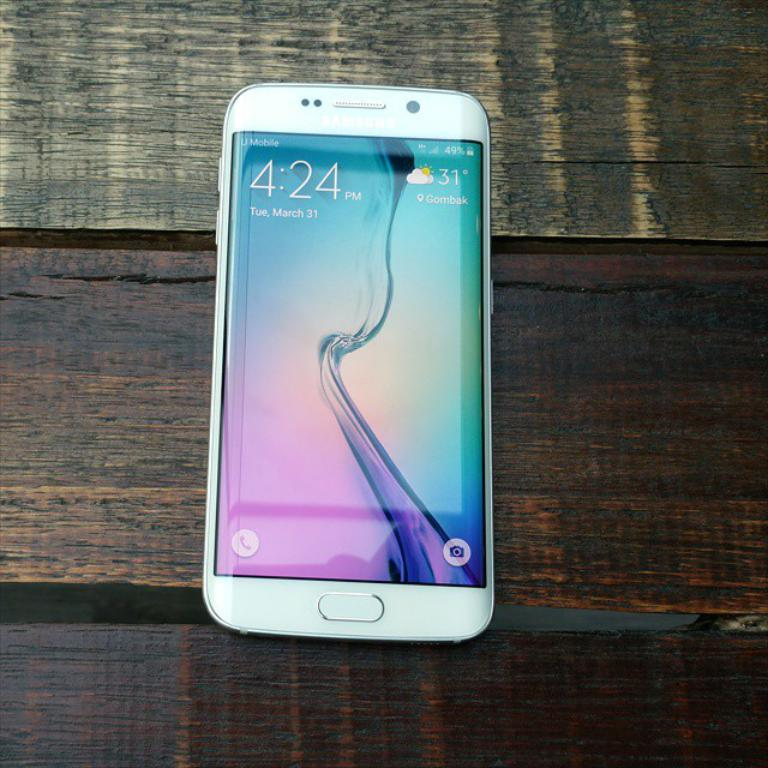<image>
Describe the image concisely. a white front faced samsung phone with the time 4:24 pm on it 